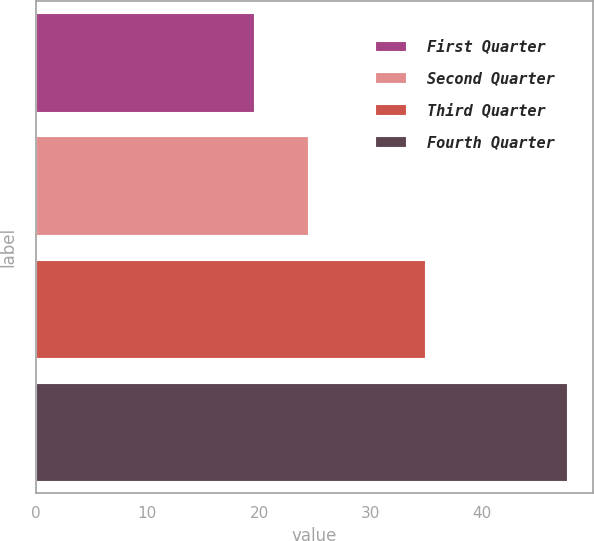Convert chart to OTSL. <chart><loc_0><loc_0><loc_500><loc_500><bar_chart><fcel>First Quarter<fcel>Second Quarter<fcel>Third Quarter<fcel>Fourth Quarter<nl><fcel>19.57<fcel>24.38<fcel>34.87<fcel>47.58<nl></chart> 